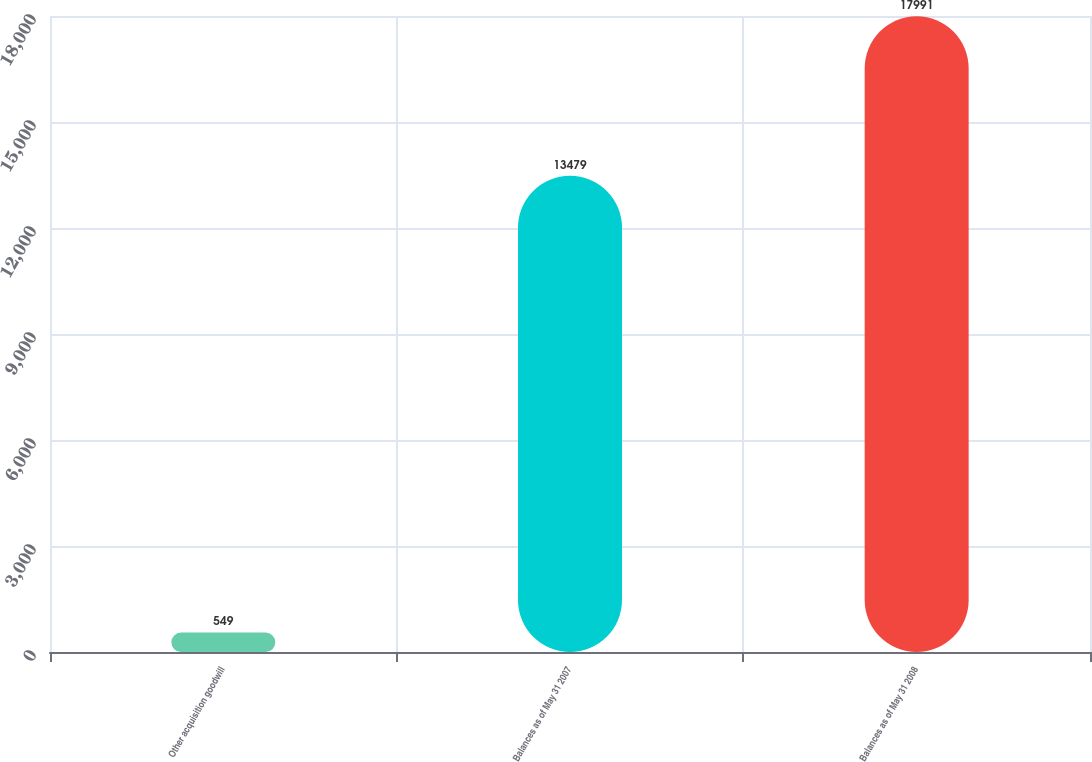Convert chart to OTSL. <chart><loc_0><loc_0><loc_500><loc_500><bar_chart><fcel>Other acquisition goodwill<fcel>Balances as of May 31 2007<fcel>Balances as of May 31 2008<nl><fcel>549<fcel>13479<fcel>17991<nl></chart> 